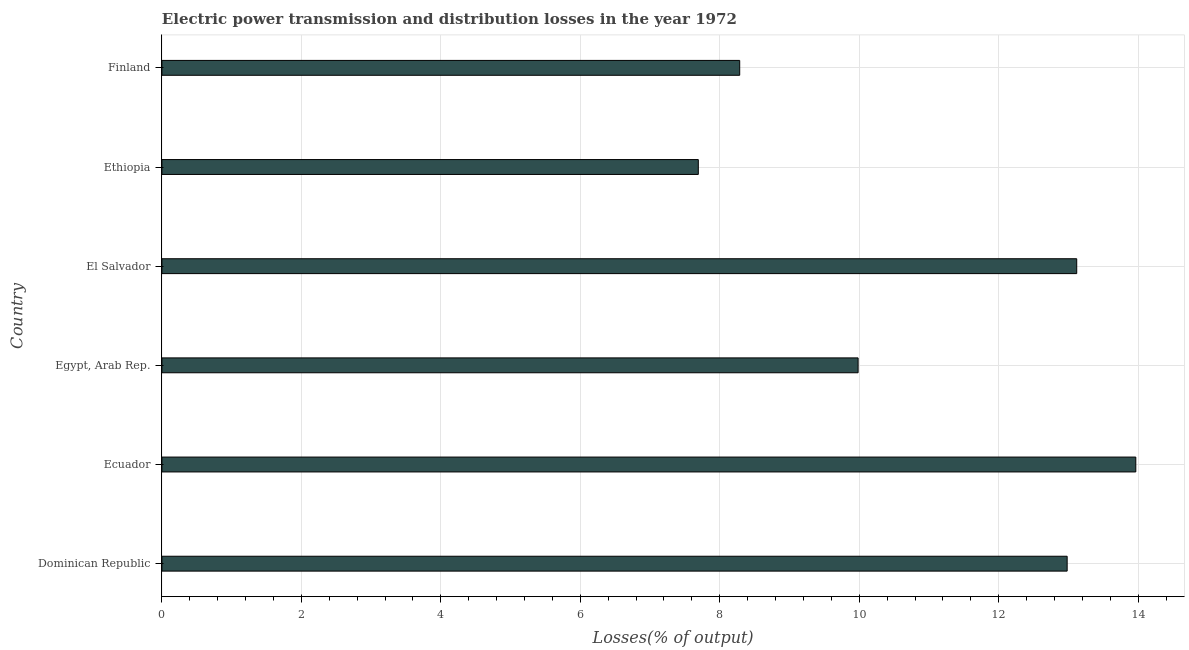Does the graph contain grids?
Provide a succinct answer. Yes. What is the title of the graph?
Offer a terse response. Electric power transmission and distribution losses in the year 1972. What is the label or title of the X-axis?
Ensure brevity in your answer.  Losses(% of output). What is the label or title of the Y-axis?
Your answer should be very brief. Country. What is the electric power transmission and distribution losses in Ecuador?
Offer a very short reply. 13.97. Across all countries, what is the maximum electric power transmission and distribution losses?
Offer a terse response. 13.97. Across all countries, what is the minimum electric power transmission and distribution losses?
Give a very brief answer. 7.69. In which country was the electric power transmission and distribution losses maximum?
Your answer should be compact. Ecuador. In which country was the electric power transmission and distribution losses minimum?
Your response must be concise. Ethiopia. What is the sum of the electric power transmission and distribution losses?
Offer a terse response. 66.03. What is the difference between the electric power transmission and distribution losses in Ethiopia and Finland?
Your answer should be compact. -0.59. What is the average electric power transmission and distribution losses per country?
Your answer should be very brief. 11.01. What is the median electric power transmission and distribution losses?
Ensure brevity in your answer.  11.48. What is the ratio of the electric power transmission and distribution losses in Dominican Republic to that in Egypt, Arab Rep.?
Your answer should be compact. 1.3. What is the difference between the highest and the second highest electric power transmission and distribution losses?
Offer a very short reply. 0.85. What is the difference between the highest and the lowest electric power transmission and distribution losses?
Make the answer very short. 6.27. How many bars are there?
Make the answer very short. 6. What is the Losses(% of output) in Dominican Republic?
Give a very brief answer. 12.98. What is the Losses(% of output) in Ecuador?
Your answer should be compact. 13.97. What is the Losses(% of output) of Egypt, Arab Rep.?
Keep it short and to the point. 9.98. What is the Losses(% of output) in El Salvador?
Your answer should be compact. 13.12. What is the Losses(% of output) of Ethiopia?
Keep it short and to the point. 7.69. What is the Losses(% of output) of Finland?
Provide a short and direct response. 8.29. What is the difference between the Losses(% of output) in Dominican Republic and Ecuador?
Give a very brief answer. -0.98. What is the difference between the Losses(% of output) in Dominican Republic and Egypt, Arab Rep.?
Provide a succinct answer. 3. What is the difference between the Losses(% of output) in Dominican Republic and El Salvador?
Provide a short and direct response. -0.14. What is the difference between the Losses(% of output) in Dominican Republic and Ethiopia?
Provide a succinct answer. 5.29. What is the difference between the Losses(% of output) in Dominican Republic and Finland?
Keep it short and to the point. 4.7. What is the difference between the Losses(% of output) in Ecuador and Egypt, Arab Rep.?
Offer a very short reply. 3.98. What is the difference between the Losses(% of output) in Ecuador and El Salvador?
Your answer should be very brief. 0.85. What is the difference between the Losses(% of output) in Ecuador and Ethiopia?
Offer a terse response. 6.27. What is the difference between the Losses(% of output) in Ecuador and Finland?
Ensure brevity in your answer.  5.68. What is the difference between the Losses(% of output) in Egypt, Arab Rep. and El Salvador?
Your answer should be compact. -3.13. What is the difference between the Losses(% of output) in Egypt, Arab Rep. and Ethiopia?
Make the answer very short. 2.29. What is the difference between the Losses(% of output) in Egypt, Arab Rep. and Finland?
Provide a succinct answer. 1.7. What is the difference between the Losses(% of output) in El Salvador and Ethiopia?
Your answer should be compact. 5.43. What is the difference between the Losses(% of output) in El Salvador and Finland?
Provide a succinct answer. 4.83. What is the difference between the Losses(% of output) in Ethiopia and Finland?
Provide a succinct answer. -0.59. What is the ratio of the Losses(% of output) in Dominican Republic to that in Ethiopia?
Offer a terse response. 1.69. What is the ratio of the Losses(% of output) in Dominican Republic to that in Finland?
Offer a terse response. 1.57. What is the ratio of the Losses(% of output) in Ecuador to that in Egypt, Arab Rep.?
Provide a succinct answer. 1.4. What is the ratio of the Losses(% of output) in Ecuador to that in El Salvador?
Make the answer very short. 1.06. What is the ratio of the Losses(% of output) in Ecuador to that in Ethiopia?
Give a very brief answer. 1.82. What is the ratio of the Losses(% of output) in Ecuador to that in Finland?
Ensure brevity in your answer.  1.69. What is the ratio of the Losses(% of output) in Egypt, Arab Rep. to that in El Salvador?
Offer a very short reply. 0.76. What is the ratio of the Losses(% of output) in Egypt, Arab Rep. to that in Ethiopia?
Your answer should be very brief. 1.3. What is the ratio of the Losses(% of output) in Egypt, Arab Rep. to that in Finland?
Give a very brief answer. 1.21. What is the ratio of the Losses(% of output) in El Salvador to that in Ethiopia?
Ensure brevity in your answer.  1.71. What is the ratio of the Losses(% of output) in El Salvador to that in Finland?
Keep it short and to the point. 1.58. What is the ratio of the Losses(% of output) in Ethiopia to that in Finland?
Your answer should be very brief. 0.93. 